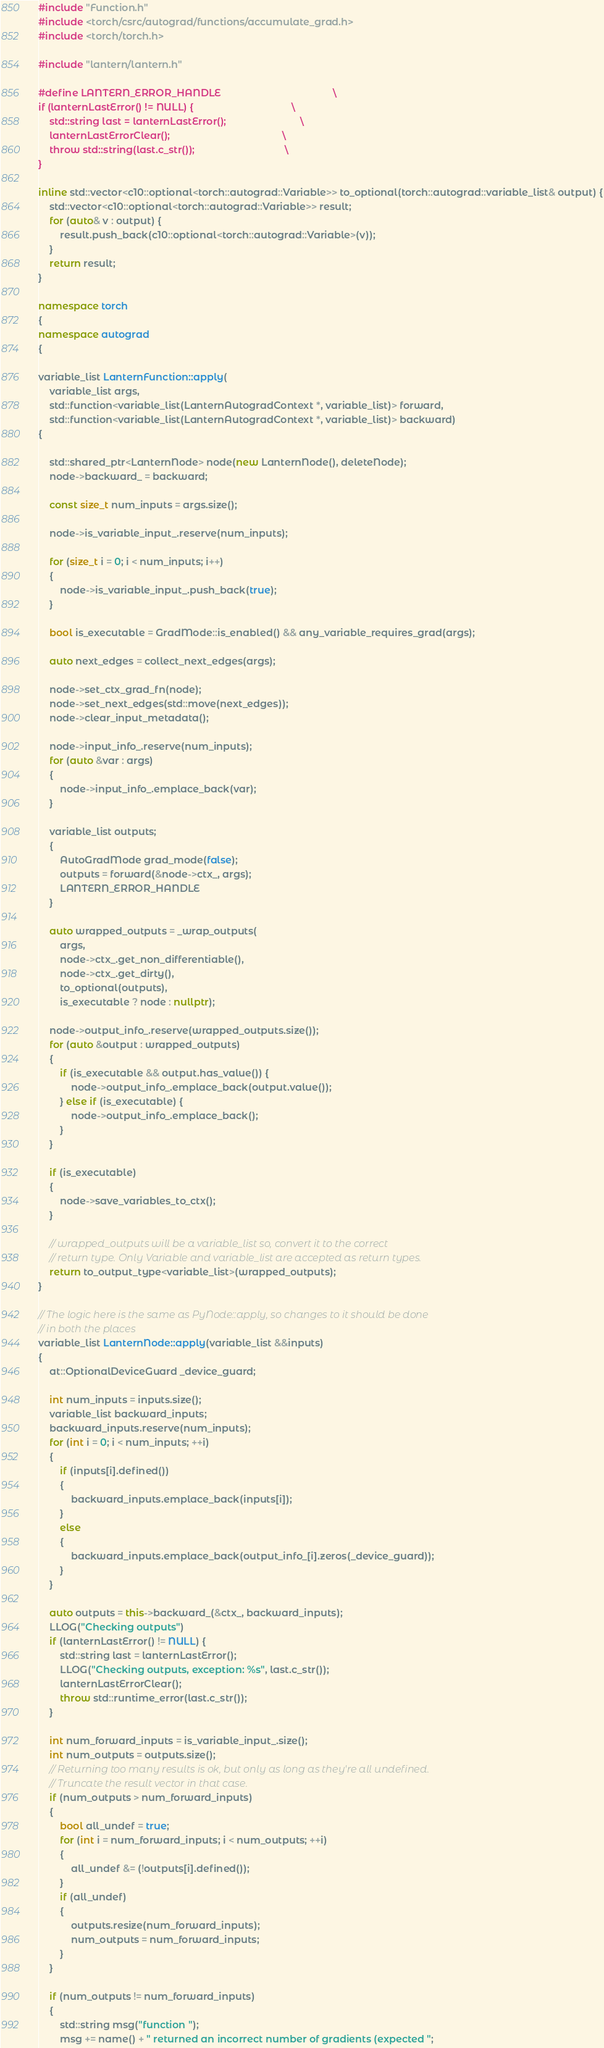<code> <loc_0><loc_0><loc_500><loc_500><_C++_>#include "Function.h"
#include <torch/csrc/autograd/functions/accumulate_grad.h>
#include <torch/torch.h>

#include "lantern/lantern.h"

#define LANTERN_ERROR_HANDLE                                         \
if (lanternLastError() != NULL) {                                    \
    std::string last = lanternLastError();                           \
    lanternLastErrorClear();                                         \
    throw std::string(last.c_str());                                 \
} 

inline std::vector<c10::optional<torch::autograd::Variable>> to_optional(torch::autograd::variable_list& output) {
    std::vector<c10::optional<torch::autograd::Variable>> result;
    for (auto& v : output) {
        result.push_back(c10::optional<torch::autograd::Variable>(v));
    }   
    return result;
}

namespace torch
{
namespace autograd
{

variable_list LanternFunction::apply(
    variable_list args,
    std::function<variable_list(LanternAutogradContext *, variable_list)> forward,
    std::function<variable_list(LanternAutogradContext *, variable_list)> backward)
{

    std::shared_ptr<LanternNode> node(new LanternNode(), deleteNode);
    node->backward_ = backward;

    const size_t num_inputs = args.size();

    node->is_variable_input_.reserve(num_inputs);

    for (size_t i = 0; i < num_inputs; i++)
    {
        node->is_variable_input_.push_back(true);
    }

    bool is_executable = GradMode::is_enabled() && any_variable_requires_grad(args);

    auto next_edges = collect_next_edges(args);

    node->set_ctx_grad_fn(node);
    node->set_next_edges(std::move(next_edges));
    node->clear_input_metadata();

    node->input_info_.reserve(num_inputs);
    for (auto &var : args)
    {
        node->input_info_.emplace_back(var);
    }

    variable_list outputs;
    {
        AutoGradMode grad_mode(false);
        outputs = forward(&node->ctx_, args);
        LANTERN_ERROR_HANDLE
    }

    auto wrapped_outputs = _wrap_outputs(
        args,
        node->ctx_.get_non_differentiable(),
        node->ctx_.get_dirty(),
        to_optional(outputs),
        is_executable ? node : nullptr);

    node->output_info_.reserve(wrapped_outputs.size());
    for (auto &output : wrapped_outputs)
    {
        if (is_executable && output.has_value()) {
            node->output_info_.emplace_back(output.value());
        } else if (is_executable) {
            node->output_info_.emplace_back();
        }
    }

    if (is_executable)
    {
        node->save_variables_to_ctx();
    }

    // wrapped_outputs will be a variable_list so, convert it to the correct
    // return type. Only Variable and variable_list are accepted as return types.
    return to_output_type<variable_list>(wrapped_outputs);
}

// The logic here is the same as PyNode::apply, so changes to it should be done
// in both the places
variable_list LanternNode::apply(variable_list &&inputs)
{
    at::OptionalDeviceGuard _device_guard;

    int num_inputs = inputs.size();
    variable_list backward_inputs;
    backward_inputs.reserve(num_inputs);
    for (int i = 0; i < num_inputs; ++i)
    {
        if (inputs[i].defined())
        {
            backward_inputs.emplace_back(inputs[i]);
        }
        else
        {
            backward_inputs.emplace_back(output_info_[i].zeros(_device_guard));
        }
    }

    auto outputs = this->backward_(&ctx_, backward_inputs);
    LLOG("Checking outputs")
    if (lanternLastError() != NULL) {
        std::string last = lanternLastError();
        LLOG("Checking outputs, exception: %s", last.c_str());
        lanternLastErrorClear();
        throw std::runtime_error(last.c_str());
    } 

    int num_forward_inputs = is_variable_input_.size();
    int num_outputs = outputs.size();
    // Returning too many results is ok, but only as long as they're all undefined.
    // Truncate the result vector in that case.
    if (num_outputs > num_forward_inputs)
    {
        bool all_undef = true;
        for (int i = num_forward_inputs; i < num_outputs; ++i)
        {
            all_undef &= (!outputs[i].defined());
        }
        if (all_undef)
        {
            outputs.resize(num_forward_inputs);
            num_outputs = num_forward_inputs;
        }
    }

    if (num_outputs != num_forward_inputs)
    {
        std::string msg("function ");
        msg += name() + " returned an incorrect number of gradients (expected ";</code> 